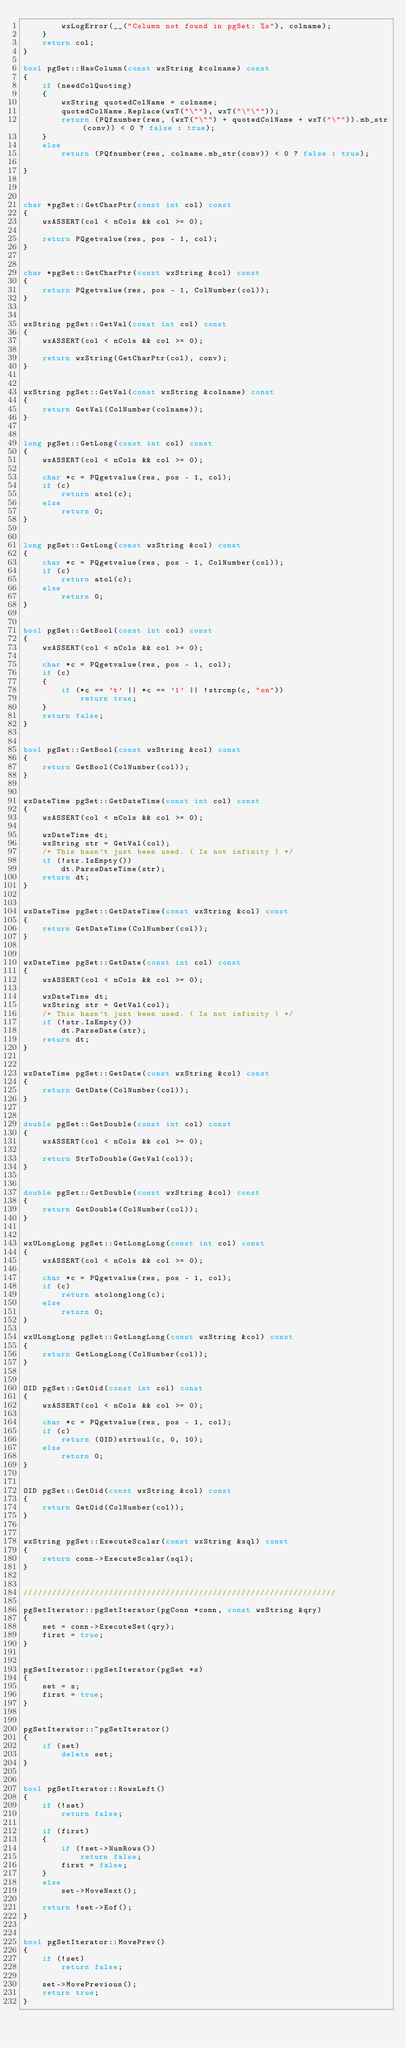<code> <loc_0><loc_0><loc_500><loc_500><_C++_>		wxLogError(__("Column not found in pgSet: %s"), colname);
	}
	return col;
}

bool pgSet::HasColumn(const wxString &colname) const
{
	if (needColQuoting)
	{
		wxString quotedColName = colname;
		quotedColName.Replace(wxT("\""), wxT("\"\""));
		return (PQfnumber(res, (wxT("\"") + quotedColName + wxT("\"")).mb_str(conv)) < 0 ? false : true);
	}
	else
		return (PQfnumber(res, colname.mb_str(conv)) < 0 ? false : true);

}



char *pgSet::GetCharPtr(const int col) const
{
	wxASSERT(col < nCols && col >= 0);

	return PQgetvalue(res, pos - 1, col);
}


char *pgSet::GetCharPtr(const wxString &col) const
{
	return PQgetvalue(res, pos - 1, ColNumber(col));
}


wxString pgSet::GetVal(const int col) const
{
	wxASSERT(col < nCols && col >= 0);

	return wxString(GetCharPtr(col), conv);
}


wxString pgSet::GetVal(const wxString &colname) const
{
	return GetVal(ColNumber(colname));
}


long pgSet::GetLong(const int col) const
{
	wxASSERT(col < nCols && col >= 0);

	char *c = PQgetvalue(res, pos - 1, col);
	if (c)
		return atol(c);
	else
		return 0;
}


long pgSet::GetLong(const wxString &col) const
{
	char *c = PQgetvalue(res, pos - 1, ColNumber(col));
	if (c)
		return atol(c);
	else
		return 0;
}


bool pgSet::GetBool(const int col) const
{
	wxASSERT(col < nCols && col >= 0);

	char *c = PQgetvalue(res, pos - 1, col);
	if (c)
	{
		if (*c == 't' || *c == '1' || !strcmp(c, "on"))
			return true;
	}
	return false;
}


bool pgSet::GetBool(const wxString &col) const
{
	return GetBool(ColNumber(col));
}


wxDateTime pgSet::GetDateTime(const int col) const
{
	wxASSERT(col < nCols && col >= 0);

	wxDateTime dt;
	wxString str = GetVal(col);
	/* This hasn't just been used. ( Is not infinity ) */
	if (!str.IsEmpty())
		dt.ParseDateTime(str);
	return dt;
}


wxDateTime pgSet::GetDateTime(const wxString &col) const
{
	return GetDateTime(ColNumber(col));
}


wxDateTime pgSet::GetDate(const int col) const
{
	wxASSERT(col < nCols && col >= 0);

	wxDateTime dt;
	wxString str = GetVal(col);
	/* This hasn't just been used. ( Is not infinity ) */
	if (!str.IsEmpty())
		dt.ParseDate(str);
	return dt;
}


wxDateTime pgSet::GetDate(const wxString &col) const
{
	return GetDate(ColNumber(col));
}


double pgSet::GetDouble(const int col) const
{
	wxASSERT(col < nCols && col >= 0);

	return StrToDouble(GetVal(col));
}


double pgSet::GetDouble(const wxString &col) const
{
	return GetDouble(ColNumber(col));
}


wxULongLong pgSet::GetLongLong(const int col) const
{
	wxASSERT(col < nCols && col >= 0);

	char *c = PQgetvalue(res, pos - 1, col);
	if (c)
		return atolonglong(c);
	else
		return 0;
}

wxULongLong pgSet::GetLongLong(const wxString &col) const
{
	return GetLongLong(ColNumber(col));
}


OID pgSet::GetOid(const int col) const
{
	wxASSERT(col < nCols && col >= 0);

	char *c = PQgetvalue(res, pos - 1, col);
	if (c)
		return (OID)strtoul(c, 0, 10);
	else
		return 0;
}


OID pgSet::GetOid(const wxString &col) const
{
	return GetOid(ColNumber(col));
}


wxString pgSet::ExecuteScalar(const wxString &sql) const
{
	return conn->ExecuteScalar(sql);
}


//////////////////////////////////////////////////////////////////

pgSetIterator::pgSetIterator(pgConn *conn, const wxString &qry)
{
	set = conn->ExecuteSet(qry);
	first = true;
}


pgSetIterator::pgSetIterator(pgSet *s)
{
	set = s;
	first = true;
}


pgSetIterator::~pgSetIterator()
{
	if (set)
		delete set;
}


bool pgSetIterator::RowsLeft()
{
	if (!set)
		return false;

	if (first)
	{
		if (!set->NumRows())
			return false;
		first = false;
	}
	else
		set->MoveNext();

	return !set->Eof();
}


bool pgSetIterator::MovePrev()
{
	if (!set)
		return false;

	set->MovePrevious();
	return true;
}
</code> 